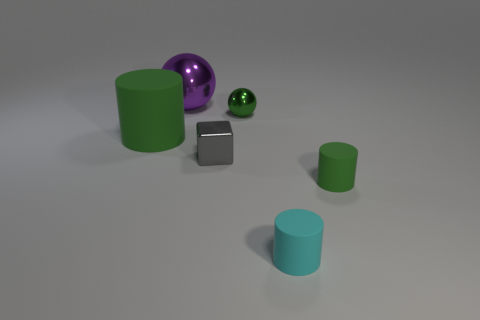There is a purple object; does it have the same shape as the shiny thing to the right of the gray metallic object?
Ensure brevity in your answer.  Yes. There is a small matte object that is the same color as the big cylinder; what is its shape?
Your answer should be very brief. Cylinder. What number of tiny cyan matte objects are in front of the tiny rubber thing in front of the small green thing right of the tiny cyan cylinder?
Provide a succinct answer. 0. How big is the metal ball right of the small object left of the tiny sphere?
Your answer should be compact. Small. What is the size of the green object that is made of the same material as the purple sphere?
Make the answer very short. Small. What shape is the green object that is both to the right of the large green matte object and behind the small metal cube?
Your answer should be very brief. Sphere. Are there an equal number of large green things on the right side of the cyan thing and big green matte cylinders?
Make the answer very short. No. What number of things are big red things or rubber cylinders that are on the left side of the gray shiny thing?
Your answer should be compact. 1. Is there a large matte object of the same shape as the big purple metallic thing?
Your answer should be very brief. No. Is the number of big purple shiny things that are behind the tiny shiny cube the same as the number of green metallic spheres behind the big shiny sphere?
Give a very brief answer. No. 